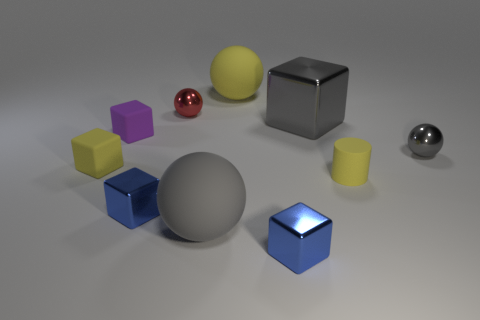Subtract all yellow blocks. How many blocks are left? 4 Subtract all purple cubes. How many cubes are left? 4 Subtract all green cubes. Subtract all red balls. How many cubes are left? 5 Subtract all cylinders. How many objects are left? 9 Add 10 green shiny blocks. How many green shiny blocks exist? 10 Subtract 0 brown spheres. How many objects are left? 10 Subtract all red spheres. Subtract all purple things. How many objects are left? 8 Add 8 tiny purple blocks. How many tiny purple blocks are left? 9 